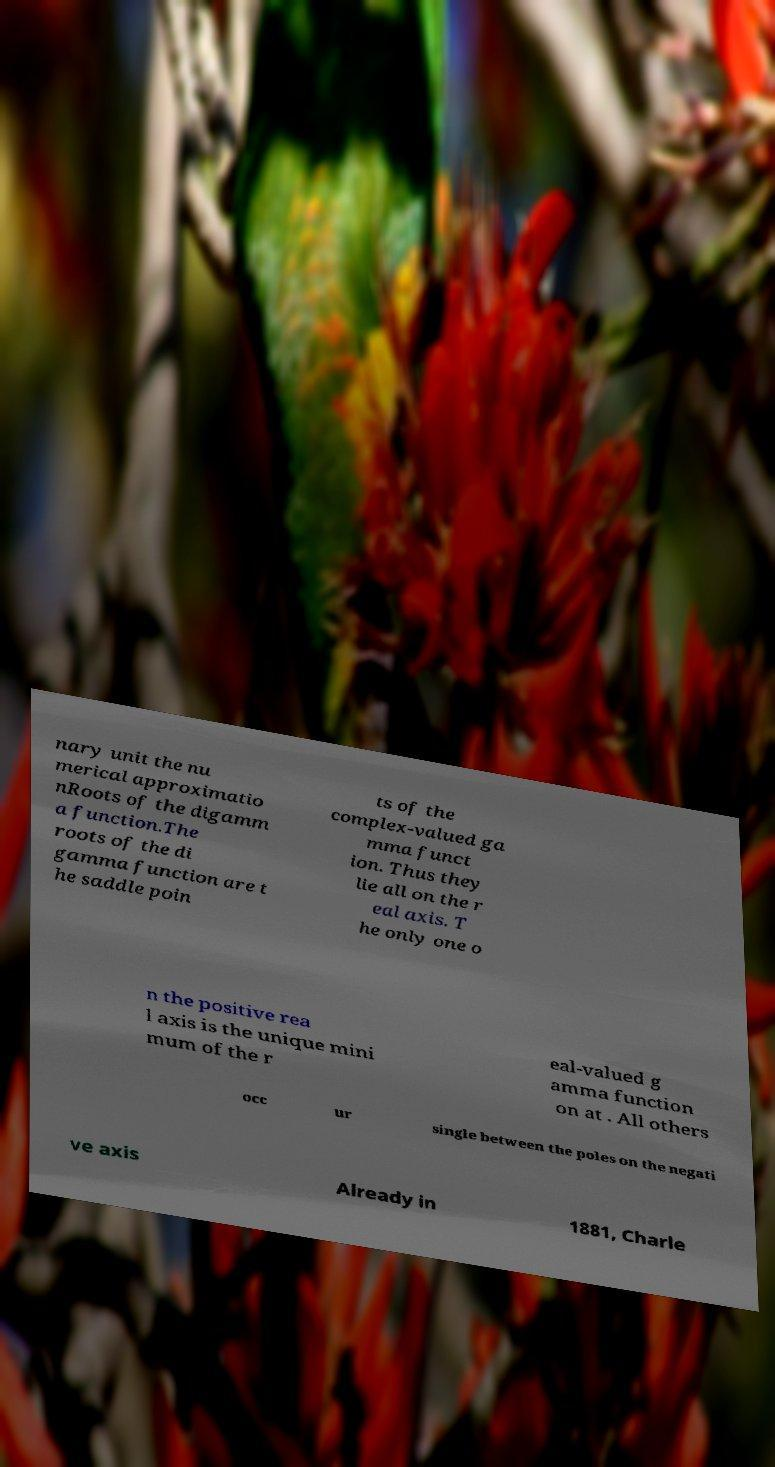Can you accurately transcribe the text from the provided image for me? nary unit the nu merical approximatio nRoots of the digamm a function.The roots of the di gamma function are t he saddle poin ts of the complex-valued ga mma funct ion. Thus they lie all on the r eal axis. T he only one o n the positive rea l axis is the unique mini mum of the r eal-valued g amma function on at . All others occ ur single between the poles on the negati ve axis Already in 1881, Charle 